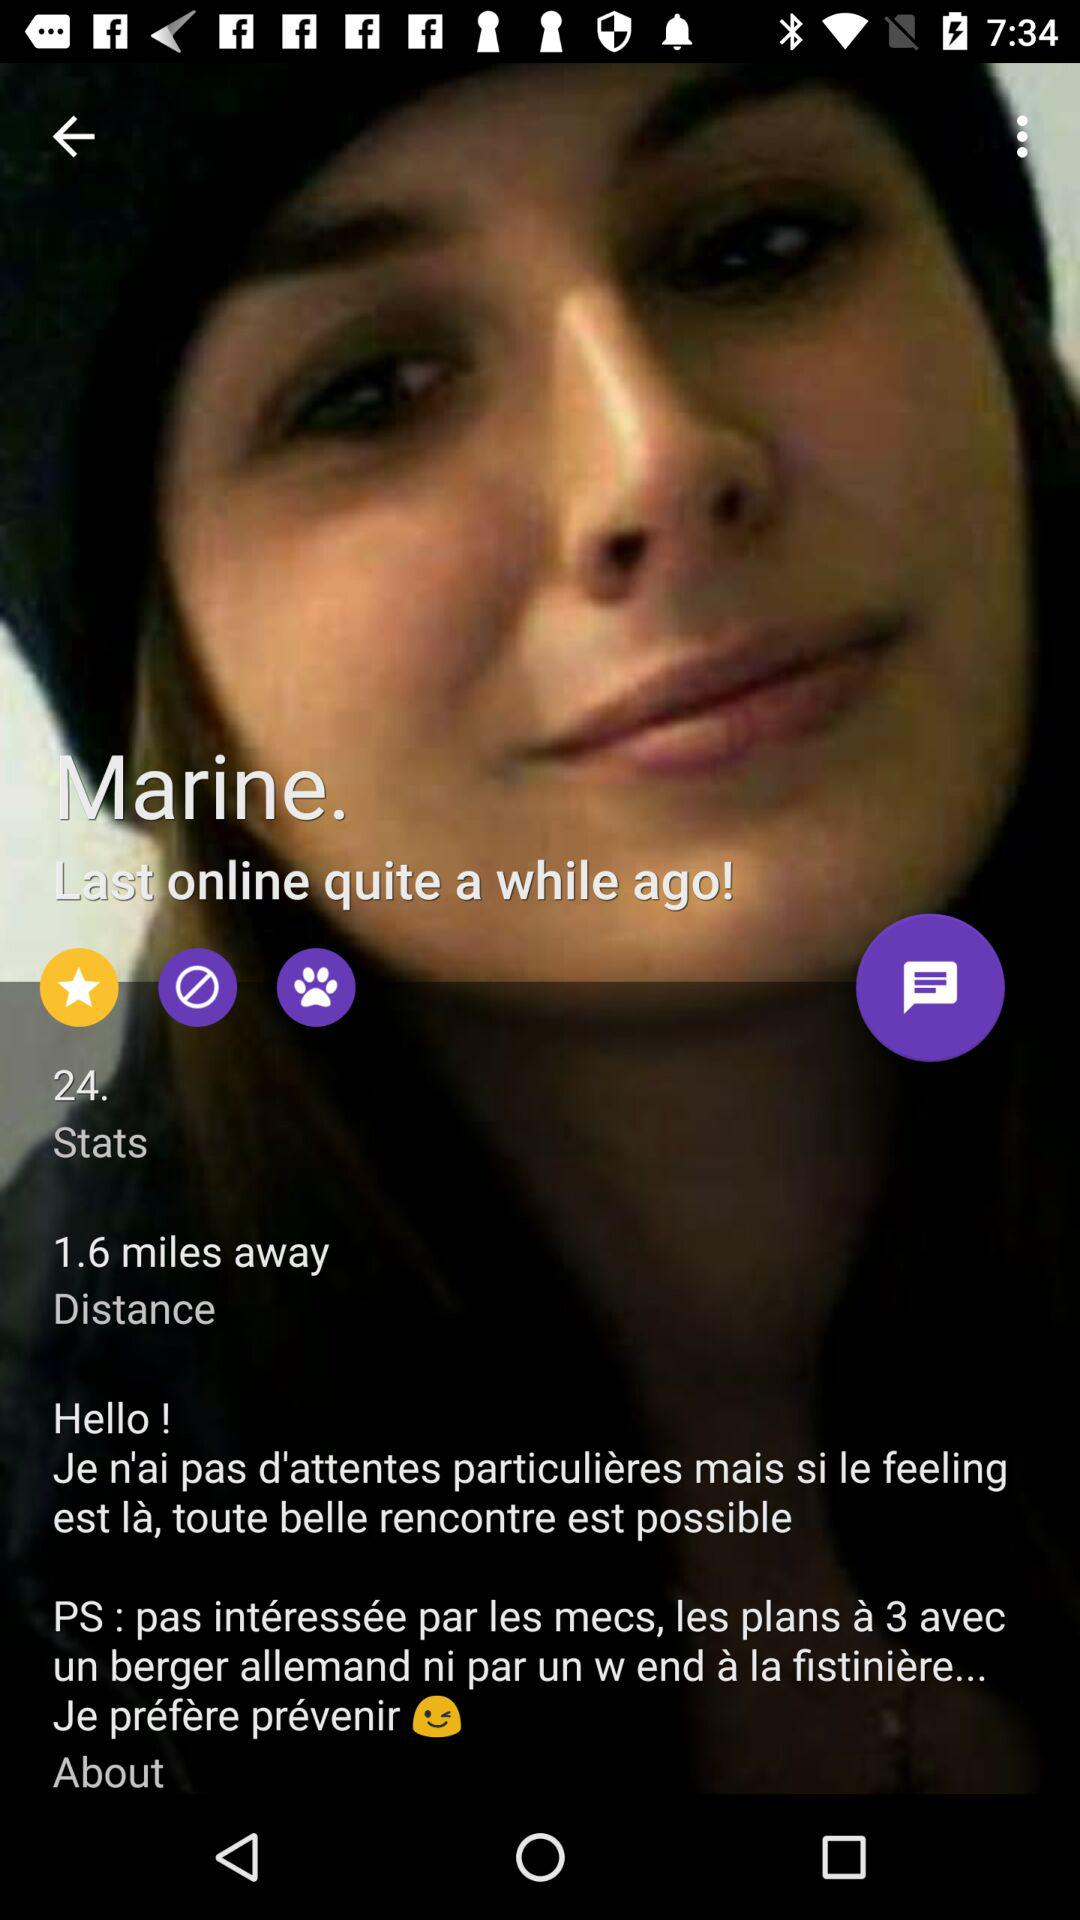What is the distance given? The distance is 1.6 miles away. 